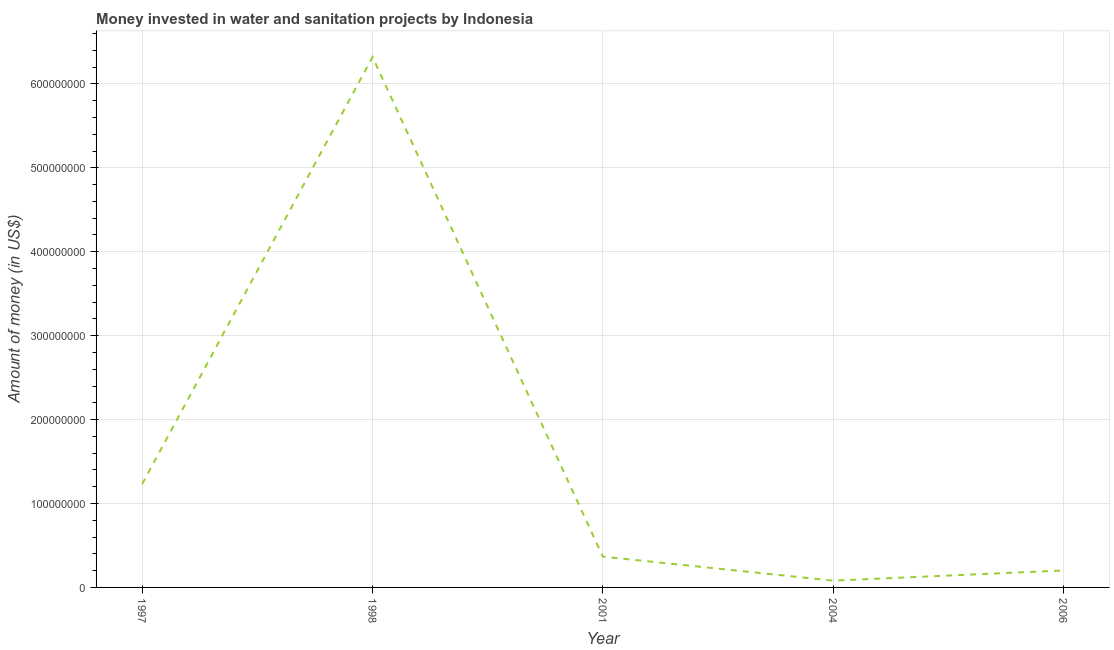What is the investment in 1997?
Provide a short and direct response. 1.23e+08. Across all years, what is the maximum investment?
Keep it short and to the point. 6.32e+08. Across all years, what is the minimum investment?
Provide a succinct answer. 8.10e+06. What is the sum of the investment?
Provide a short and direct response. 8.20e+08. What is the difference between the investment in 1997 and 2006?
Your response must be concise. 1.03e+08. What is the average investment per year?
Your answer should be compact. 1.64e+08. What is the median investment?
Offer a terse response. 3.67e+07. Do a majority of the years between 2004 and 1997 (inclusive) have investment greater than 180000000 US$?
Give a very brief answer. Yes. What is the ratio of the investment in 1997 to that in 2006?
Offer a terse response. 6.1. What is the difference between the highest and the second highest investment?
Your answer should be very brief. 5.09e+08. What is the difference between the highest and the lowest investment?
Provide a succinct answer. 6.24e+08. In how many years, is the investment greater than the average investment taken over all years?
Make the answer very short. 1. What is the difference between two consecutive major ticks on the Y-axis?
Offer a terse response. 1.00e+08. Are the values on the major ticks of Y-axis written in scientific E-notation?
Your answer should be compact. No. Does the graph contain any zero values?
Offer a very short reply. No. What is the title of the graph?
Offer a terse response. Money invested in water and sanitation projects by Indonesia. What is the label or title of the X-axis?
Keep it short and to the point. Year. What is the label or title of the Y-axis?
Your response must be concise. Amount of money (in US$). What is the Amount of money (in US$) in 1997?
Offer a very short reply. 1.23e+08. What is the Amount of money (in US$) of 1998?
Provide a succinct answer. 6.32e+08. What is the Amount of money (in US$) in 2001?
Provide a short and direct response. 3.67e+07. What is the Amount of money (in US$) of 2004?
Offer a very short reply. 8.10e+06. What is the Amount of money (in US$) of 2006?
Offer a terse response. 2.02e+07. What is the difference between the Amount of money (in US$) in 1997 and 1998?
Make the answer very short. -5.09e+08. What is the difference between the Amount of money (in US$) in 1997 and 2001?
Your answer should be compact. 8.65e+07. What is the difference between the Amount of money (in US$) in 1997 and 2004?
Offer a terse response. 1.15e+08. What is the difference between the Amount of money (in US$) in 1997 and 2006?
Give a very brief answer. 1.03e+08. What is the difference between the Amount of money (in US$) in 1998 and 2001?
Offer a very short reply. 5.95e+08. What is the difference between the Amount of money (in US$) in 1998 and 2004?
Make the answer very short. 6.24e+08. What is the difference between the Amount of money (in US$) in 1998 and 2006?
Provide a short and direct response. 6.12e+08. What is the difference between the Amount of money (in US$) in 2001 and 2004?
Provide a short and direct response. 2.86e+07. What is the difference between the Amount of money (in US$) in 2001 and 2006?
Make the answer very short. 1.65e+07. What is the difference between the Amount of money (in US$) in 2004 and 2006?
Make the answer very short. -1.21e+07. What is the ratio of the Amount of money (in US$) in 1997 to that in 1998?
Offer a very short reply. 0.2. What is the ratio of the Amount of money (in US$) in 1997 to that in 2001?
Offer a terse response. 3.36. What is the ratio of the Amount of money (in US$) in 1997 to that in 2004?
Make the answer very short. 15.21. What is the ratio of the Amount of money (in US$) in 1997 to that in 2006?
Offer a terse response. 6.1. What is the ratio of the Amount of money (in US$) in 1998 to that in 2001?
Offer a very short reply. 17.22. What is the ratio of the Amount of money (in US$) in 1998 to that in 2004?
Your answer should be compact. 78.03. What is the ratio of the Amount of money (in US$) in 1998 to that in 2006?
Ensure brevity in your answer.  31.29. What is the ratio of the Amount of money (in US$) in 2001 to that in 2004?
Make the answer very short. 4.53. What is the ratio of the Amount of money (in US$) in 2001 to that in 2006?
Your response must be concise. 1.82. What is the ratio of the Amount of money (in US$) in 2004 to that in 2006?
Make the answer very short. 0.4. 